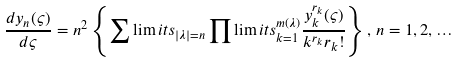<formula> <loc_0><loc_0><loc_500><loc_500>\frac { d y _ { n } ( \varsigma ) } { d \varsigma } = n ^ { 2 } \left \{ \sum \lim i t s _ { | \lambda | = n } \prod \lim i t s _ { k = 1 } ^ { m ( \lambda ) } \frac { y _ { k } ^ { r _ { k } } ( \varsigma ) } { k ^ { r _ { k } } r _ { k } ! } \right \} , \, n = 1 , 2 , \dots</formula> 